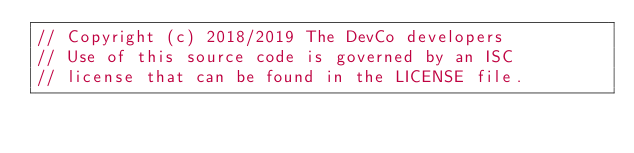Convert code to text. <code><loc_0><loc_0><loc_500><loc_500><_Go_>// Copyright (c) 2018/2019 The DevCo developers
// Use of this source code is governed by an ISC
// license that can be found in the LICENSE file.
</code> 